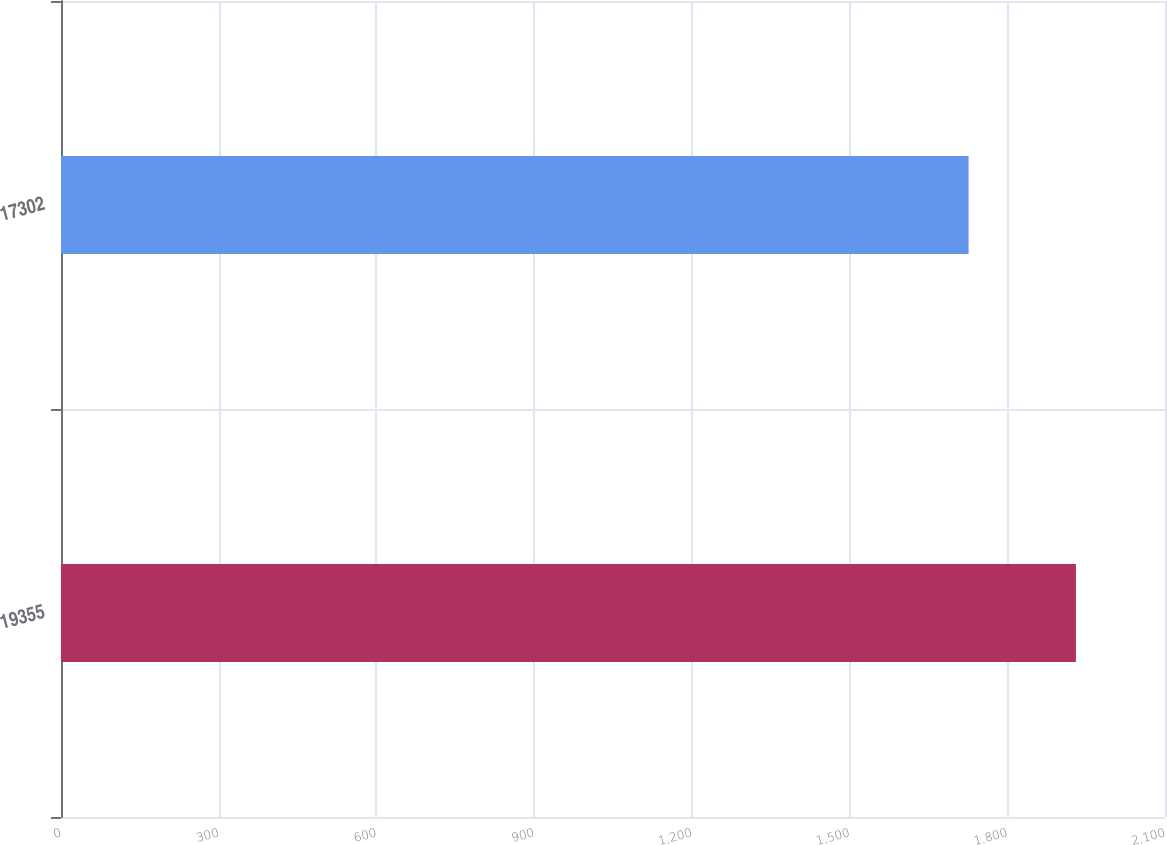<chart> <loc_0><loc_0><loc_500><loc_500><bar_chart><fcel>19355<fcel>17302<nl><fcel>1930.6<fcel>1726.4<nl></chart> 